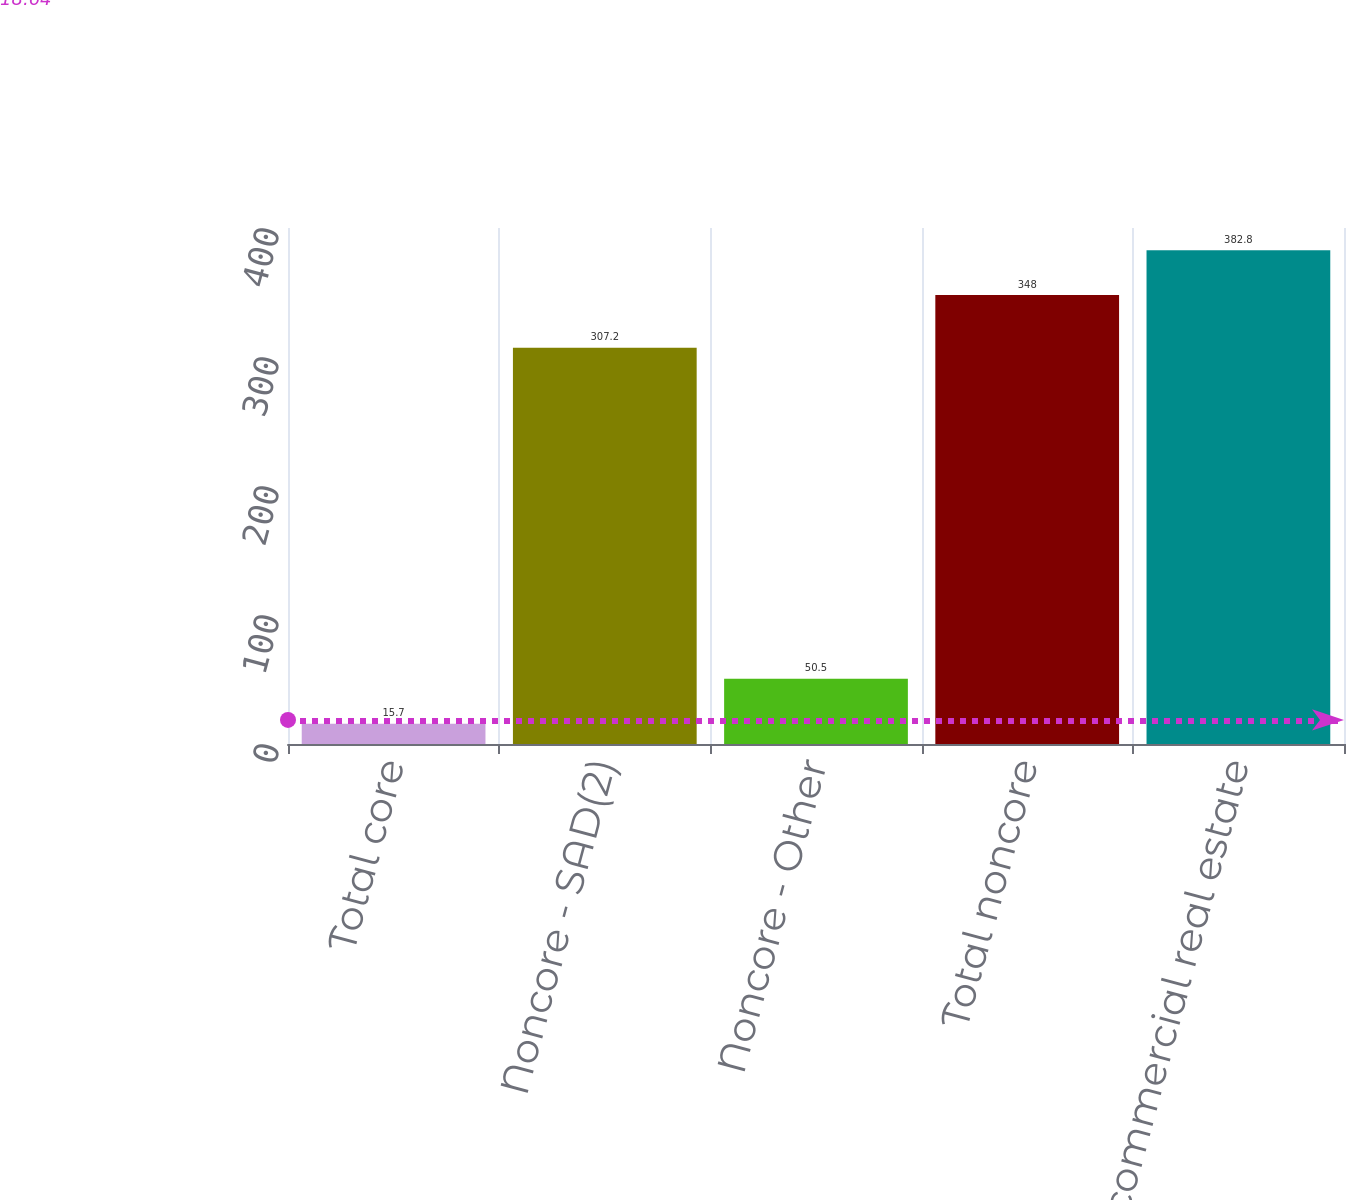Convert chart to OTSL. <chart><loc_0><loc_0><loc_500><loc_500><bar_chart><fcel>Total core<fcel>Noncore - SAD(2)<fcel>Noncore - Other<fcel>Total noncore<fcel>Total commercial real estate<nl><fcel>15.7<fcel>307.2<fcel>50.5<fcel>348<fcel>382.8<nl></chart> 